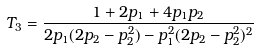<formula> <loc_0><loc_0><loc_500><loc_500>T _ { 3 } = \frac { 1 + 2 p _ { 1 } + 4 p _ { 1 } p _ { 2 } } { 2 p _ { 1 } ( 2 p _ { 2 } - p _ { 2 } ^ { 2 } ) - p _ { 1 } ^ { 2 } ( 2 p _ { 2 } - p _ { 2 } ^ { 2 } ) ^ { 2 } }</formula> 